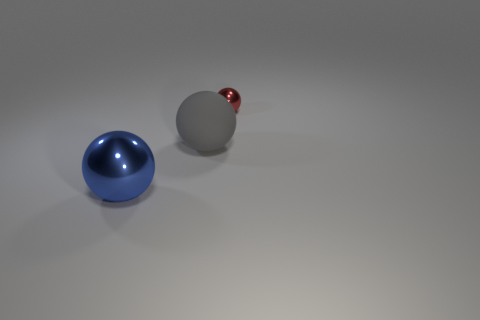Are there any other things that have the same material as the gray object?
Make the answer very short. No. What is the shape of the large thing that is behind the large metallic ball in front of the large ball that is behind the big blue object?
Your answer should be compact. Sphere. Is the red object the same size as the rubber ball?
Your answer should be compact. No. How many things are big gray rubber spheres or large balls that are in front of the gray sphere?
Offer a very short reply. 2. How many things are big gray balls that are to the left of the red metallic object or big things to the right of the big blue ball?
Keep it short and to the point. 1. There is a small red shiny object; are there any large things to the right of it?
Ensure brevity in your answer.  No. There is a metallic ball behind the shiny object to the left of the metal thing that is right of the big gray rubber sphere; what is its color?
Offer a very short reply. Red. Does the small red shiny thing have the same shape as the large blue thing?
Offer a terse response. Yes. What is the color of the large sphere that is the same material as the small sphere?
Provide a succinct answer. Blue. What number of objects are either spheres to the left of the red ball or spheres?
Offer a terse response. 3. 